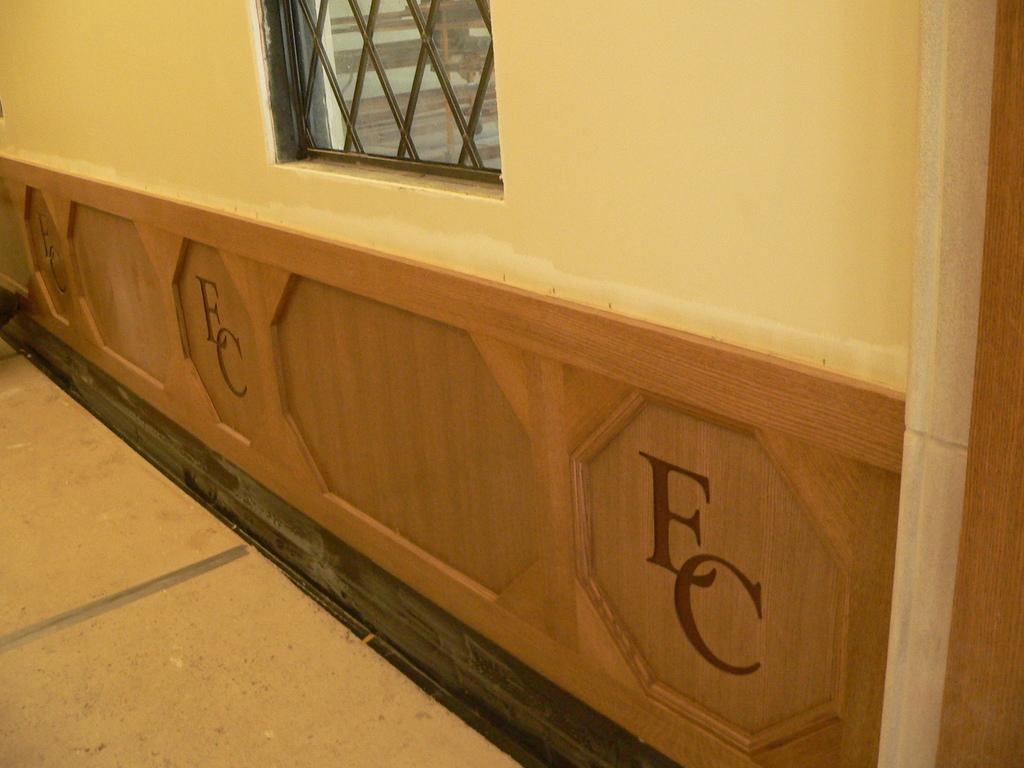Can you describe this image briefly? In this image there is a wall and on the wall there is a window and there is some text written on the wall. 